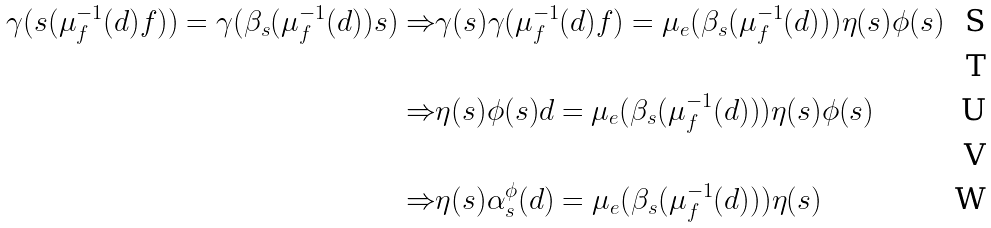Convert formula to latex. <formula><loc_0><loc_0><loc_500><loc_500>\gamma ( s ( \mu _ { f } ^ { - 1 } ( d ) f ) ) = \gamma ( \beta _ { s } ( \mu _ { f } ^ { - 1 } ( d ) ) s ) \Rightarrow & \gamma ( s ) \gamma ( \mu _ { f } ^ { - 1 } ( d ) f ) = \mu _ { e } ( \beta _ { s } ( \mu _ { f } ^ { - 1 } ( d ) ) ) \eta ( s ) \phi ( s ) \\ \\ \Rightarrow & \eta ( s ) \phi ( s ) d = \mu _ { e } ( \beta _ { s } ( \mu _ { f } ^ { - 1 } ( d ) ) ) \eta ( s ) \phi ( s ) \\ \\ \Rightarrow & \eta ( s ) \alpha ^ { \phi } _ { s } ( d ) = \mu _ { e } ( \beta _ { s } ( \mu _ { f } ^ { - 1 } ( d ) ) ) \eta ( s )</formula> 